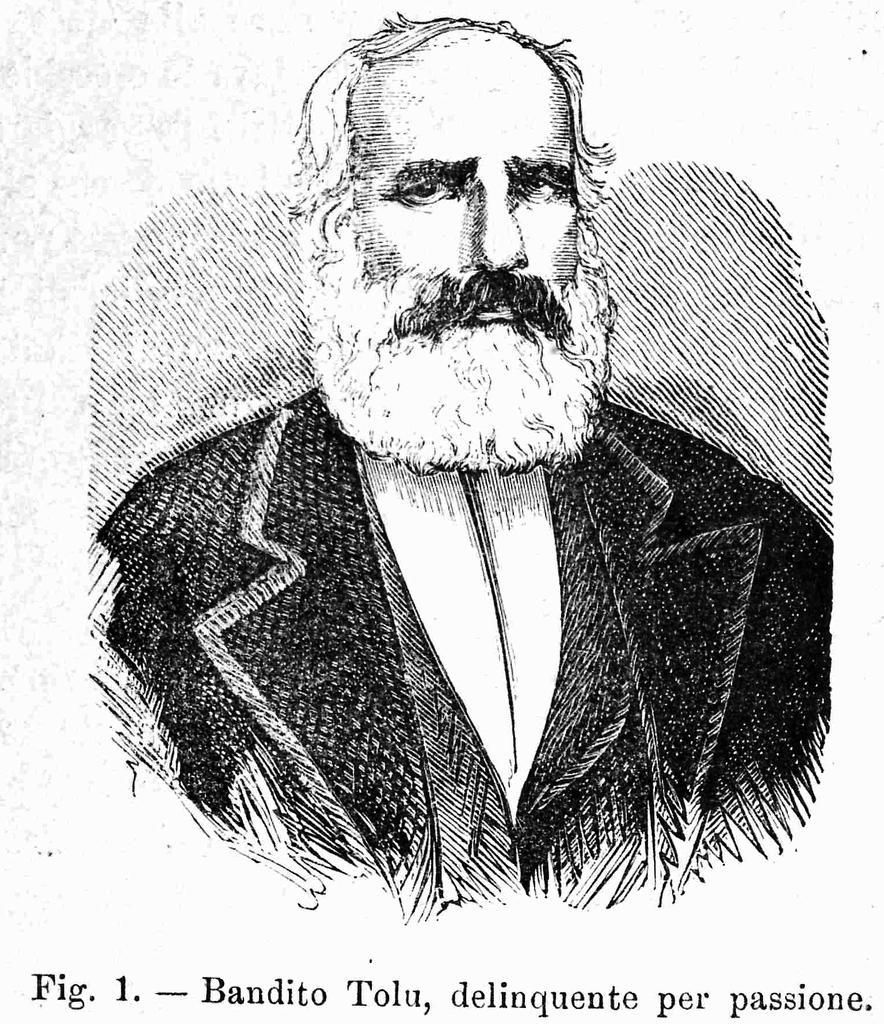In one or two sentences, can you explain what this image depicts? In this image we can see a poster of a person who is wearing suits and bottom of the image there are some words written. 